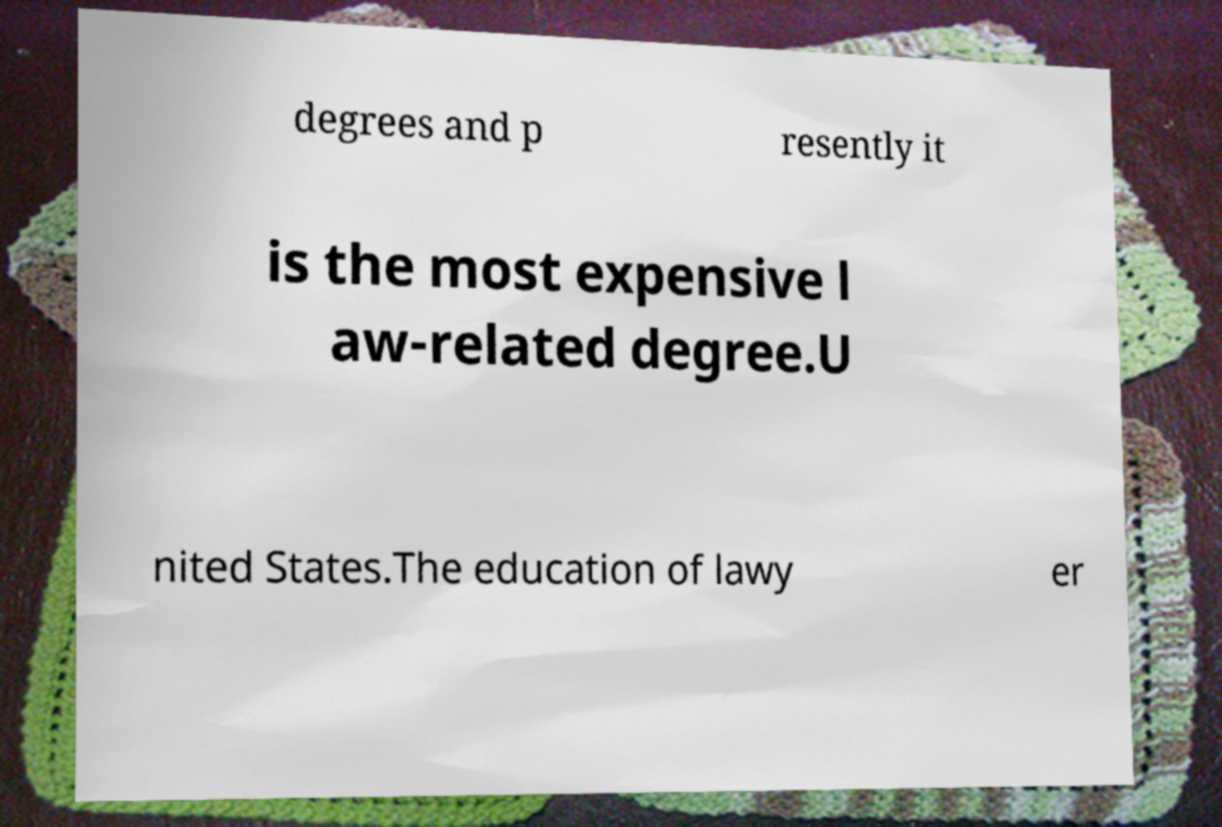Please read and relay the text visible in this image. What does it say? degrees and p resently it is the most expensive l aw-related degree.U nited States.The education of lawy er 